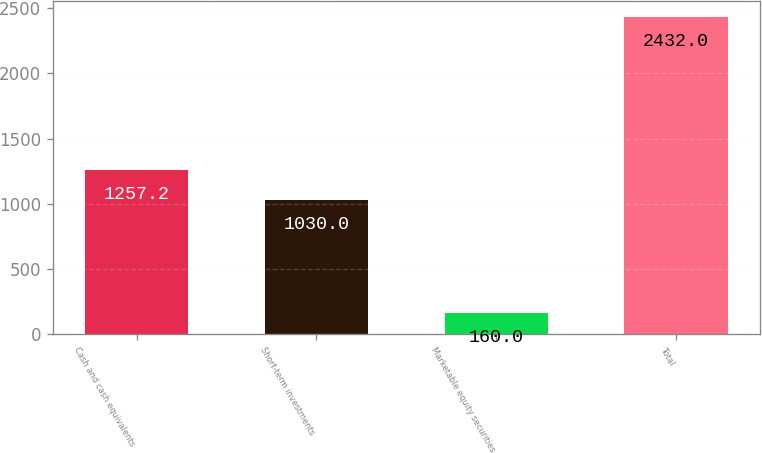Convert chart to OTSL. <chart><loc_0><loc_0><loc_500><loc_500><bar_chart><fcel>Cash and cash equivalents<fcel>Short-term investments<fcel>Marketable equity securities<fcel>Total<nl><fcel>1257.2<fcel>1030<fcel>160<fcel>2432<nl></chart> 